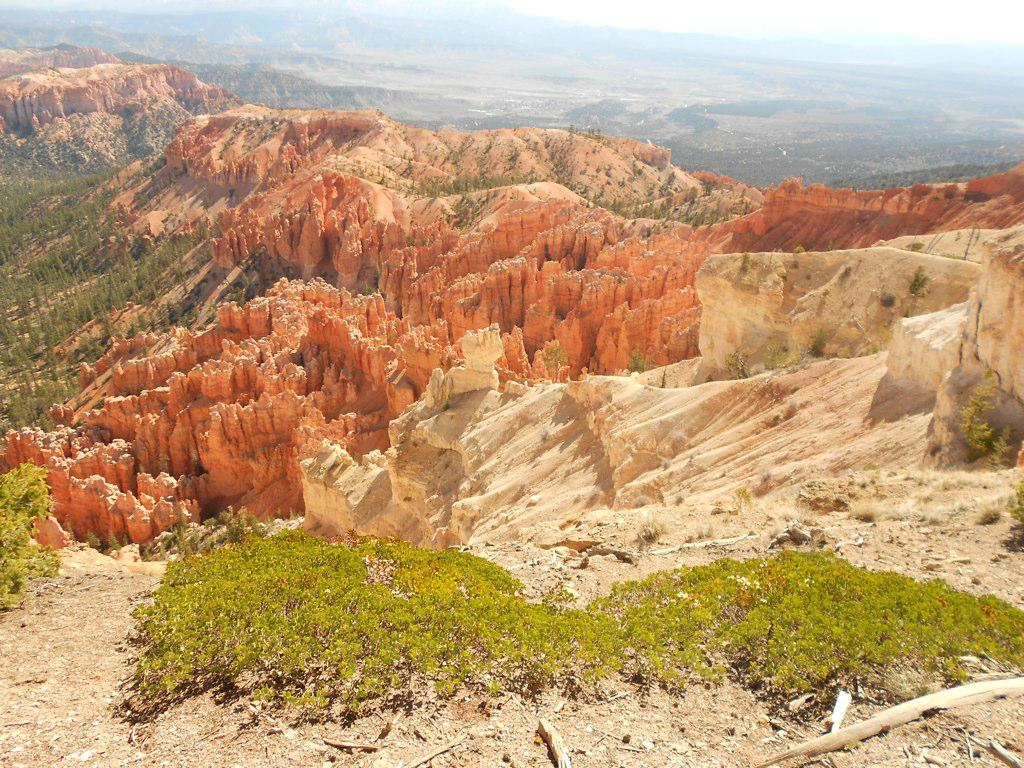What type of natural environment is depicted in the image? The image features grass and mountains. What part of the natural environment is visible in the image? The sky is visible in the image. What is the name of the daughter who lives in the mountains in the image? There is no mention of a daughter or any living beings in the image; it only features grass, mountains, and the sky. What type of magic can be seen happening in the image? There is no magic or any supernatural elements present in the image. 